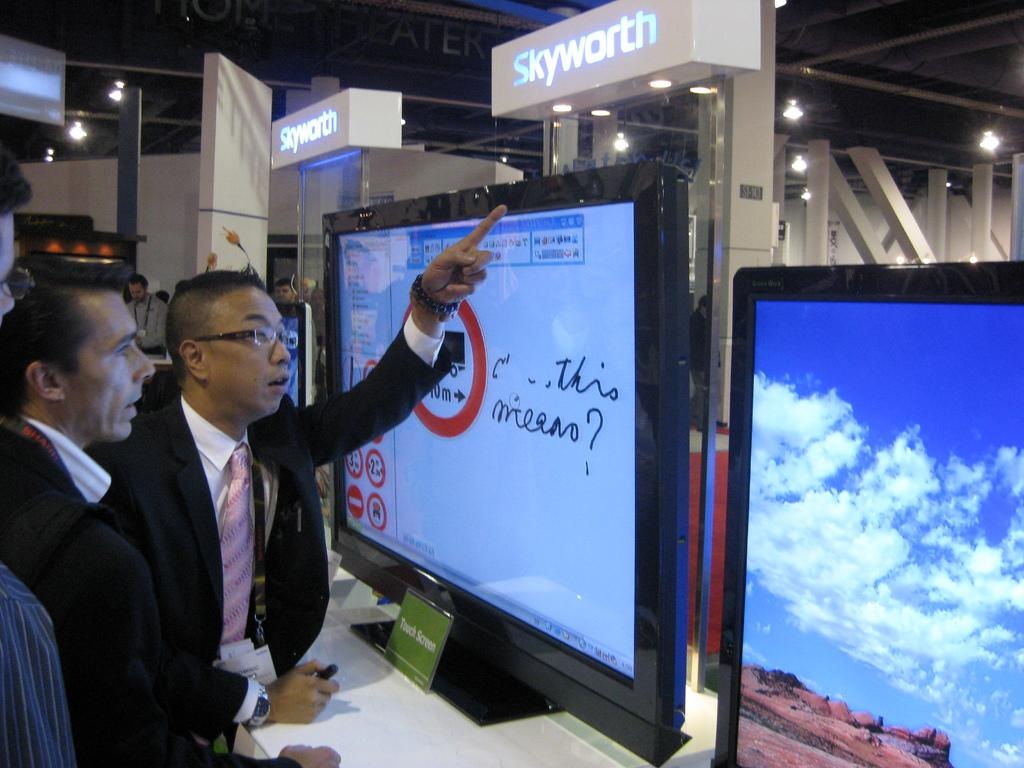What can be seen on the left side of the image? There are people on the left side of the image. Can you describe the attire of one of the people? One person is wearing a suit and tie. What type of furniture is present in the image? There is a white table in the image. What is placed on the white table? There are monitors on the white table. What can be seen illuminating the scene in the image? There are lights visible in the image. What type of coastline can be seen in the image? There is no coastline present in the image; it features people, a white table, monitors, and lights. What selection of items is available for the person wearing a suit and tie? The provided facts do not mention any selection of items for the person wearing a suit and tie. 